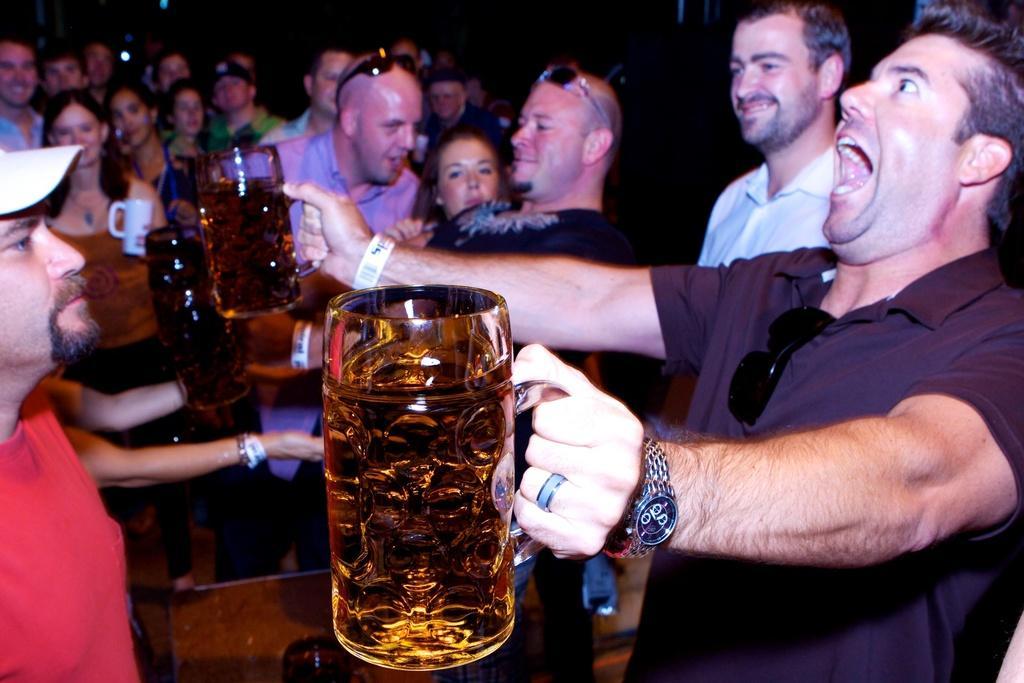Please provide a concise description of this image. Here there are many people standing both men and women. On the right there is a man holding wine glasses in his both hands. 